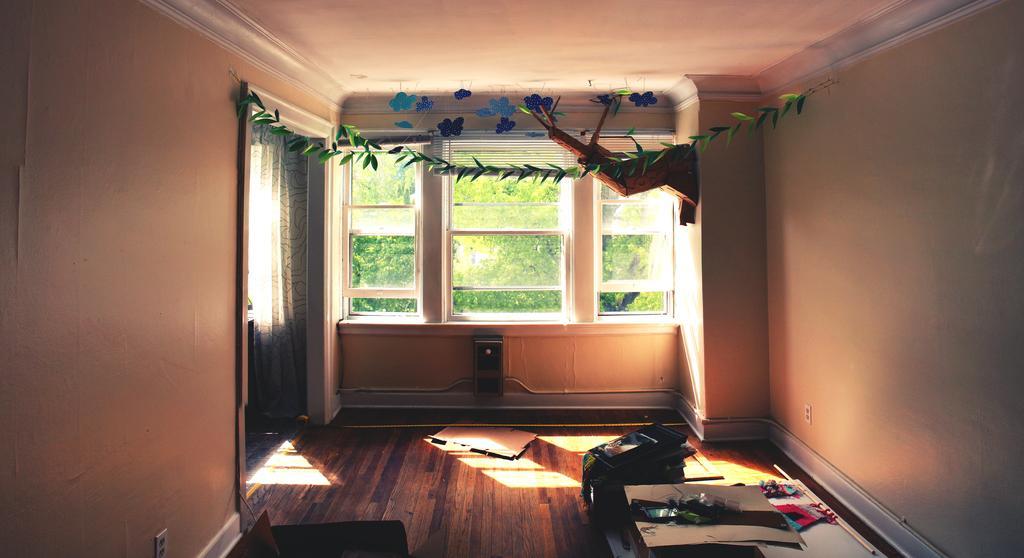Could you give a brief overview of what you see in this image? This picture shows an inner view of a room we see a stick and a few papers on the floor and we see a curtain and a Window from the window we see trees and we see a printer on the floor. 